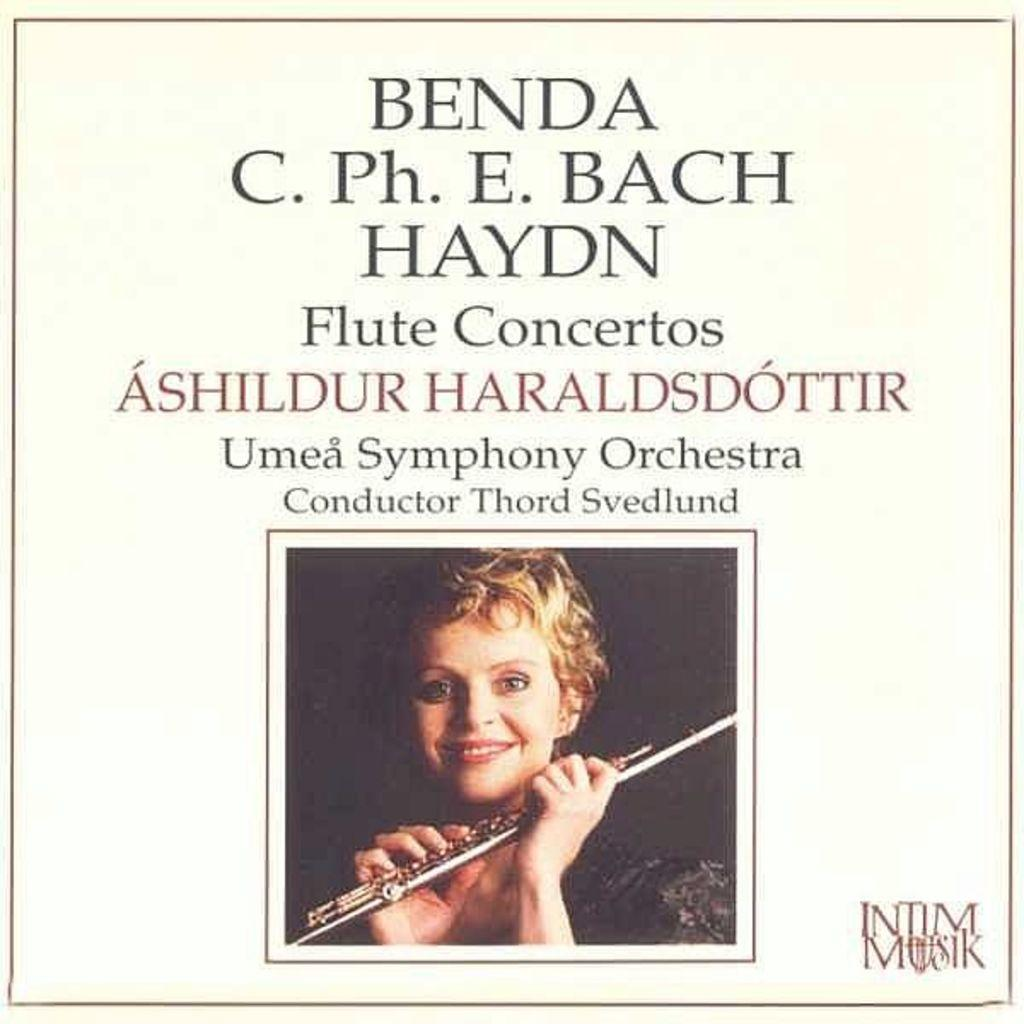What type of visual is the image? The image is a poster. What can be found at the top of the poster? There is text at the top of the poster. Who or what is the main subject of the poster? There is a person in the center of the poster. What is the person holding in the poster? The person is holding a stick. What type of exchange is taking place between the person and the army in the image? There is no army present in the image, and no exchange is depicted. 